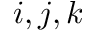Convert formula to latex. <formula><loc_0><loc_0><loc_500><loc_500>i , j , k</formula> 